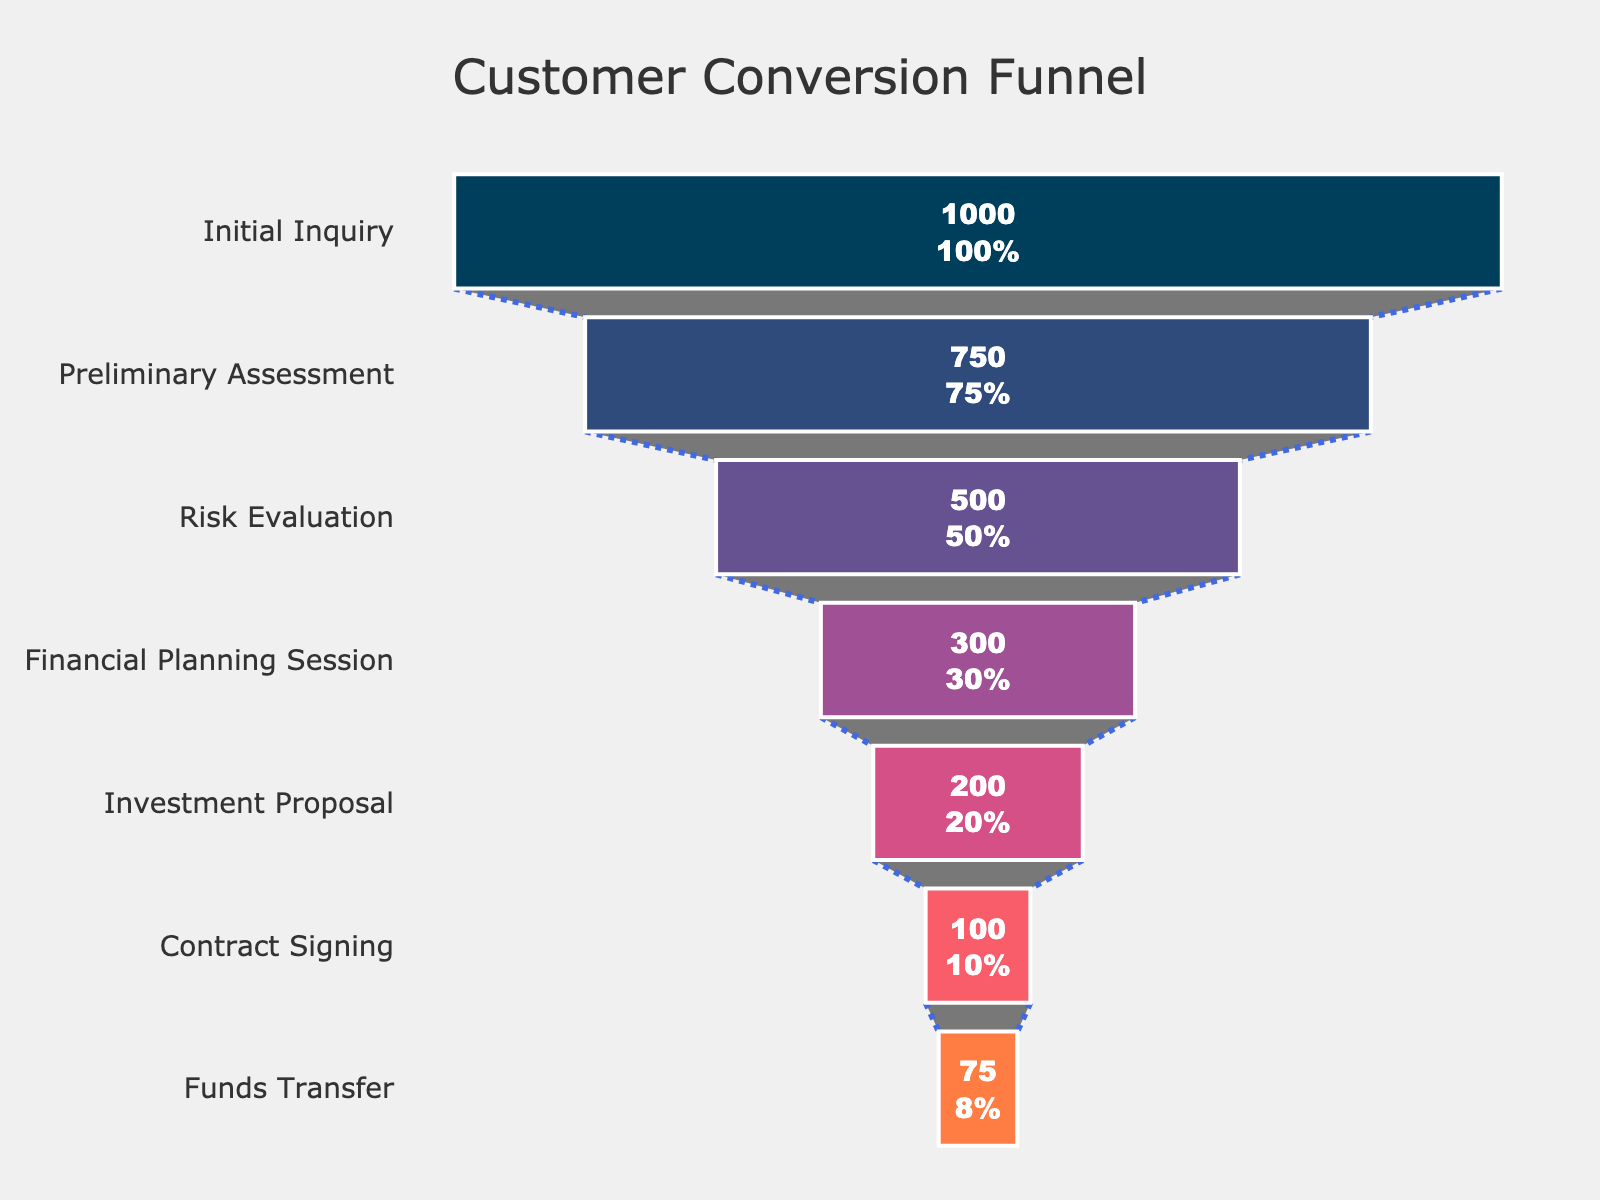What is the title of the Funnel Chart? The title is clearly displayed at the top center of the chart. It states: "Customer Conversion Funnel".
Answer: Customer Conversion Funnel How many stages are shown in the funnel? Count the number of distinct stages listed along the vertical axis. There are seven stages.
Answer: Seven Which stage has the highest number of prospects? The stage with the highest number of prospects is evident from the topmost part of the funnel. It is "Initial Inquiry" with 1000 prospects.
Answer: Initial Inquiry What is the percentage drop from Initial Inquiry to Preliminary Assessment? Calculate the percentage drop by taking the difference between the prospects of these stages (1000 - 750 = 250) and dividing it by the initial number of prospects (1000), then multiply by 100. ((1000 - 750) / 1000) * 100
Answer: 25% What is the difference in the number of prospects between Financial Planning Session and Contract Signing? Subtract the number of prospects at the Contract Signing stage from the Financial Planning Session stage (300 - 100 = 200).
Answer: 200 What is the percentage of prospects that reach the Funds Transfer stage from Initial Inquiry? The percentage can be calculated by taking the number at the Funds Transfer stage, dividing by the initial number, and multiplying by 100. (75 / 1000) * 100
Answer: 7.5% What stage has the least number of prospects? By observing the lowest point in the funnel chart, we see that "Funds Transfer" has the least prospects, which is 75.
Answer: Funds Transfer By how much does the number of prospects decrease from Risk Evaluation to Funds Transfer? Calculate the difference by subtracting the end number from the starting number, i.e., 500 - 75 = 425.
Answer: 425 Which two stages show an equal percentage drop? Comparing percentage drops between stages, Preliminary Assessment to Risk Evaluation and Financial Planning Session to Investment Proposal both show a 33.33% drop.
Answer: Preliminary Assessment to Risk Evaluation and Financial Planning Session to Investment Proposal 